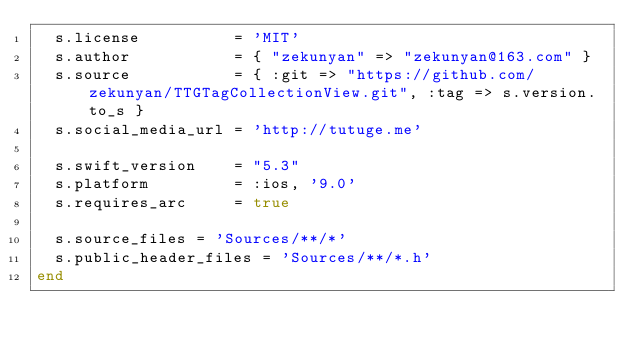Convert code to text. <code><loc_0><loc_0><loc_500><loc_500><_Ruby_>  s.license          = 'MIT'
  s.author           = { "zekunyan" => "zekunyan@163.com" }
  s.source           = { :git => "https://github.com/zekunyan/TTGTagCollectionView.git", :tag => s.version.to_s }
  s.social_media_url = 'http://tutuge.me'

  s.swift_version    = "5.3"
  s.platform         = :ios, '9.0'
  s.requires_arc     = true

  s.source_files = 'Sources/**/*'
  s.public_header_files = 'Sources/**/*.h'
end
</code> 